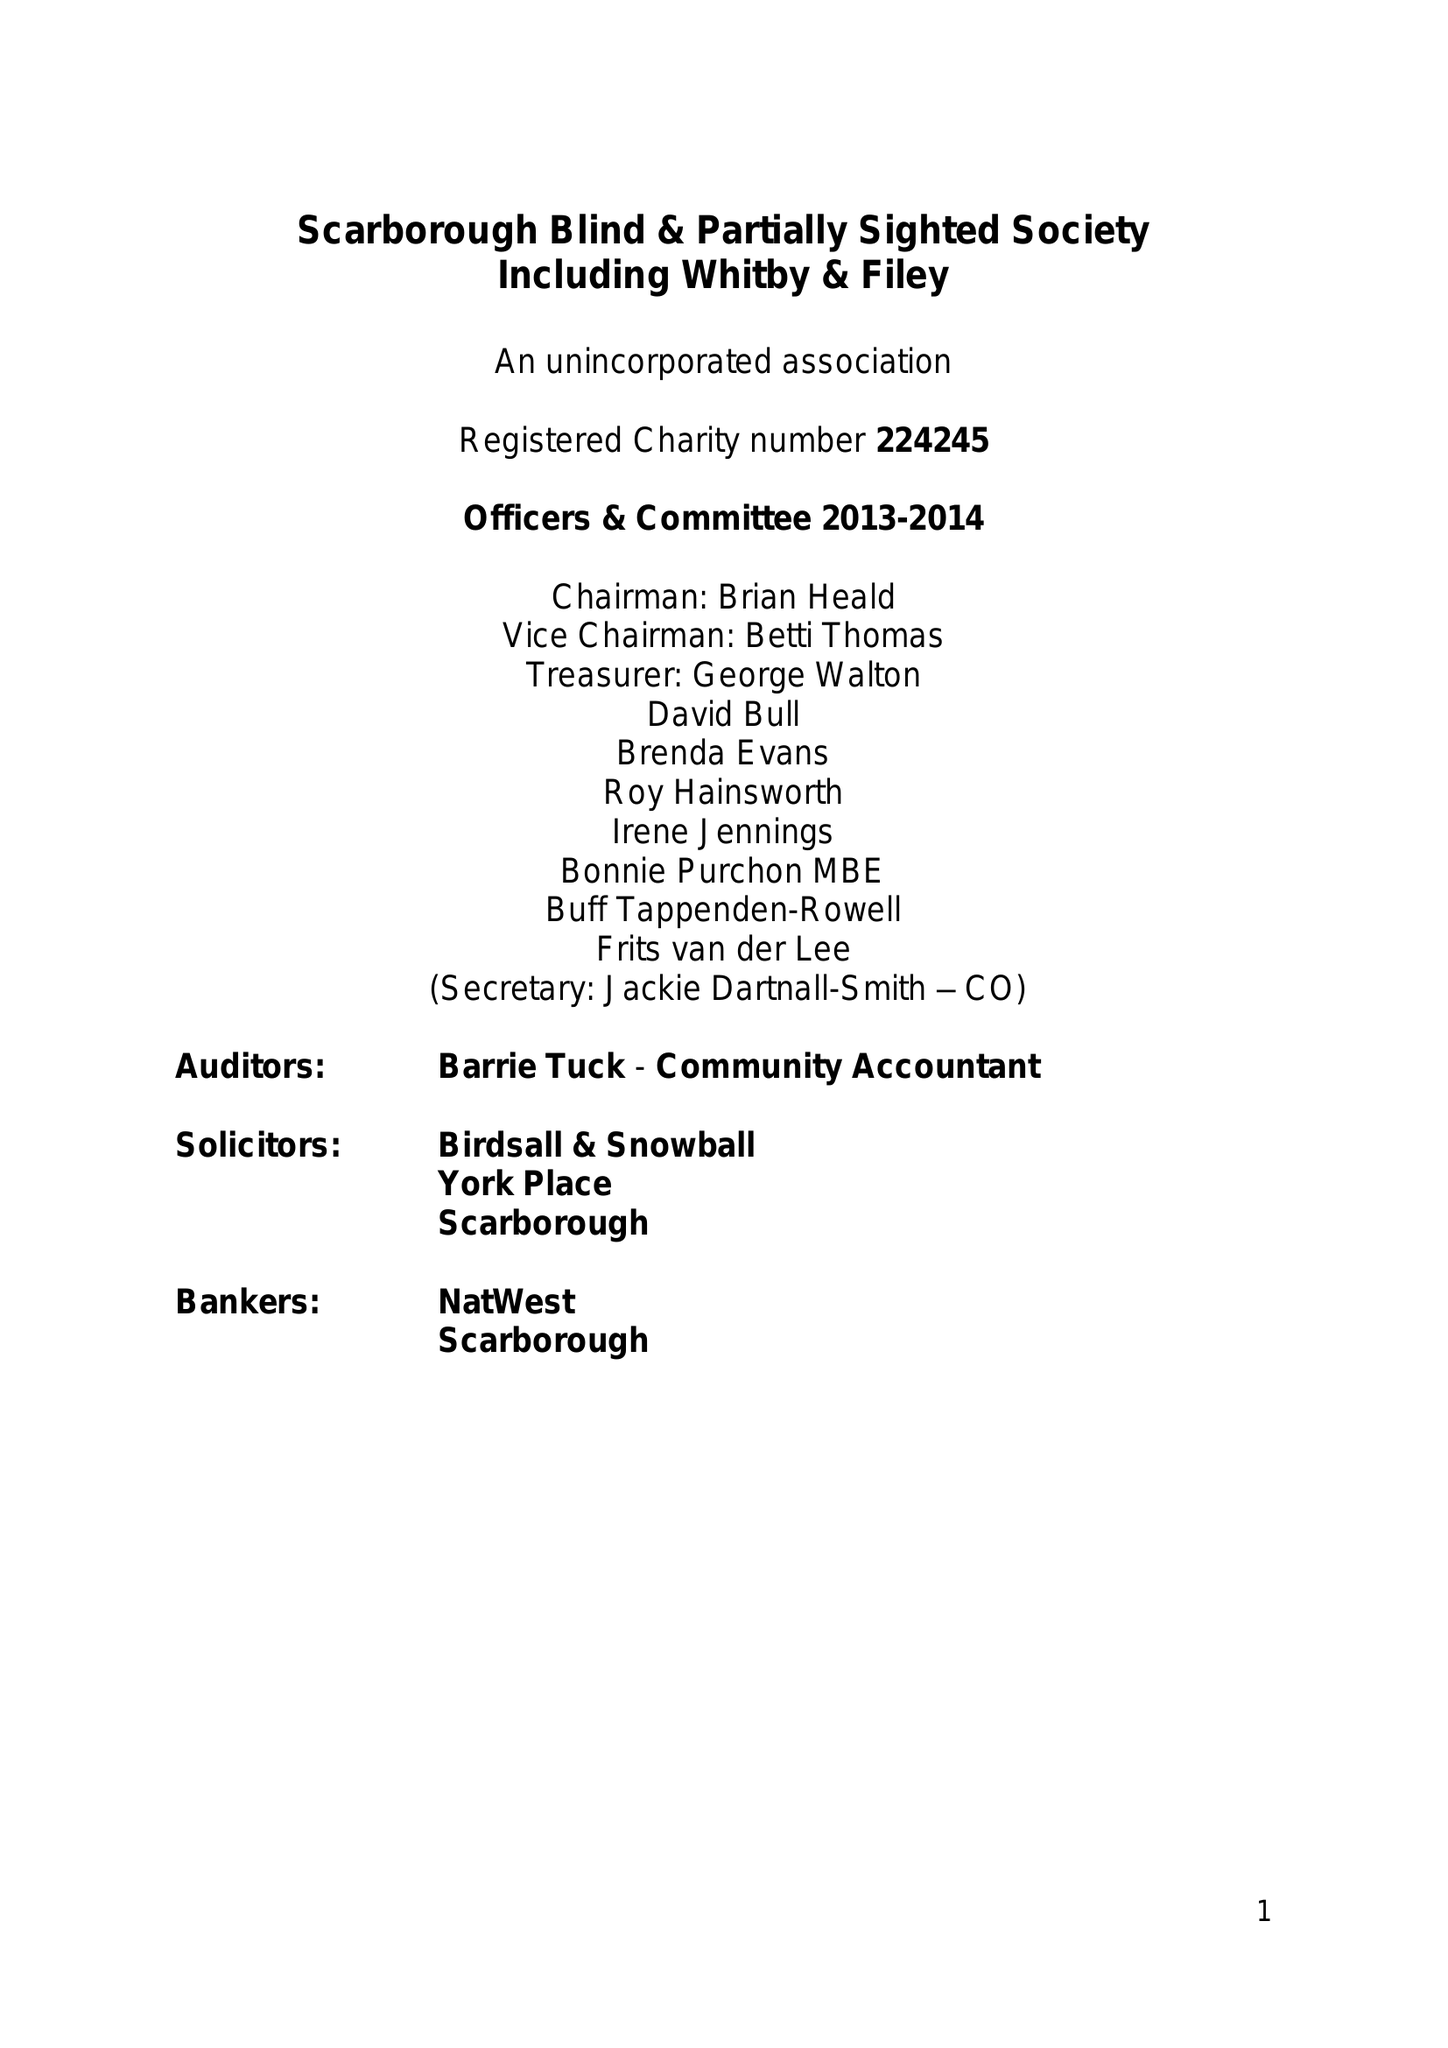What is the value for the charity_name?
Answer the question using a single word or phrase. Yorkshire Coast Sight Support 